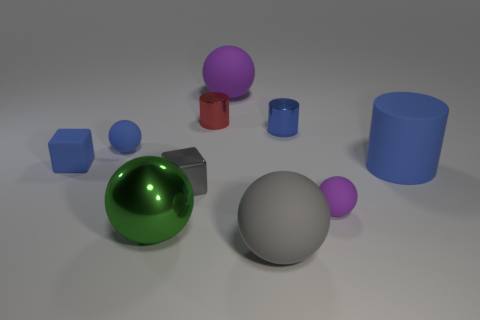Subtract all blue matte cylinders. How many cylinders are left? 2 Subtract all yellow spheres. How many blue cylinders are left? 2 Subtract all purple spheres. How many spheres are left? 3 Subtract 1 cylinders. How many cylinders are left? 2 Subtract all yellow cylinders. Subtract all blue spheres. How many cylinders are left? 3 Subtract all cylinders. How many objects are left? 7 Subtract all small cyan spheres. Subtract all tiny gray blocks. How many objects are left? 9 Add 6 small blue balls. How many small blue balls are left? 7 Add 1 big shiny balls. How many big shiny balls exist? 2 Subtract 1 green balls. How many objects are left? 9 